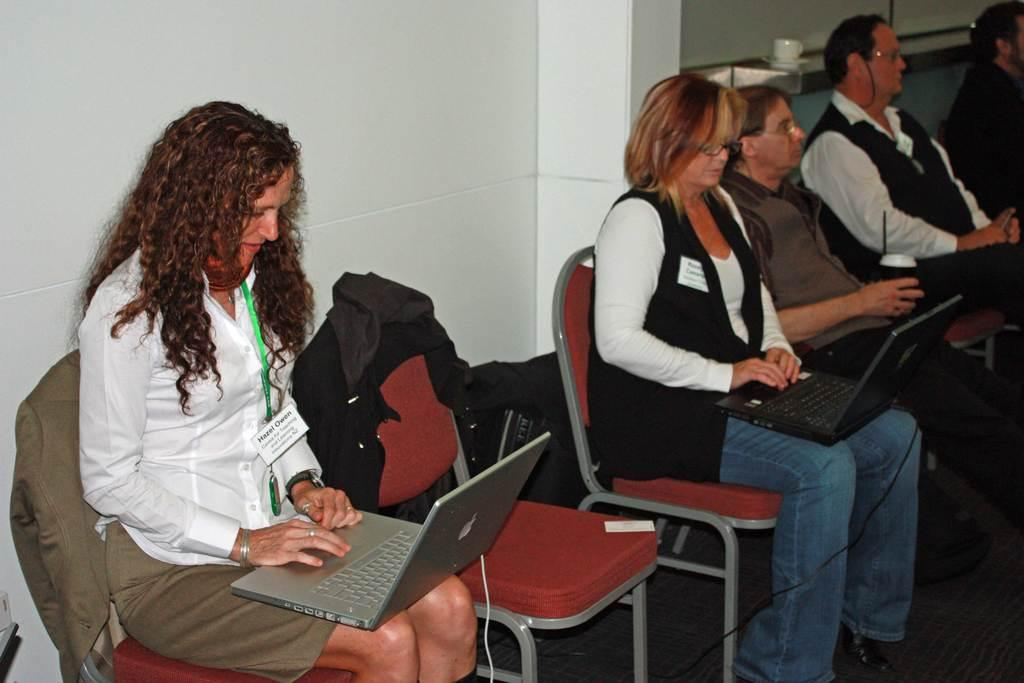What are the people in the image doing? The people in the image are sitting on chairs. What electronic devices can be seen in the image? There are laptops visible in the image. Can you describe an object in the background of the image? There is a cup in the background of the image. What is the price of the mask worn by the maid in the image? There is no mask or maid present in the image. 